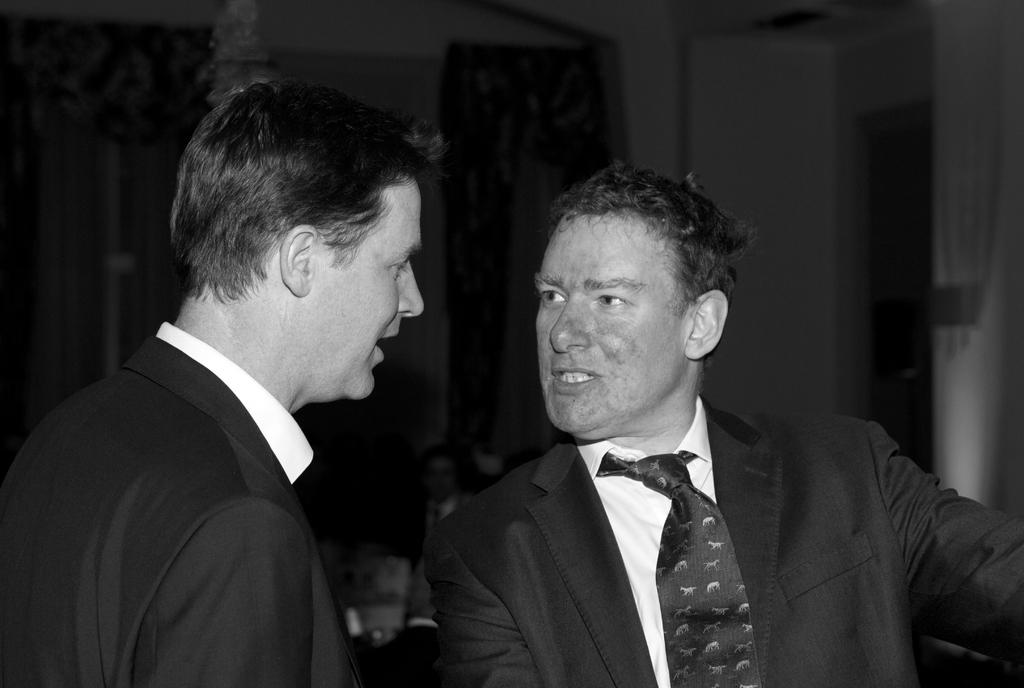How many people are in the image? There are two men in the image. What are the men doing in the image? The men are talking to each other. What are the men wearing in the image? Both men are wearing suits. Can you describe any distinguishing features of one of the men? One of the men has marks on his face. What type of glove is the man wearing on his head in the image? There is no glove present on either man's head in the image. 